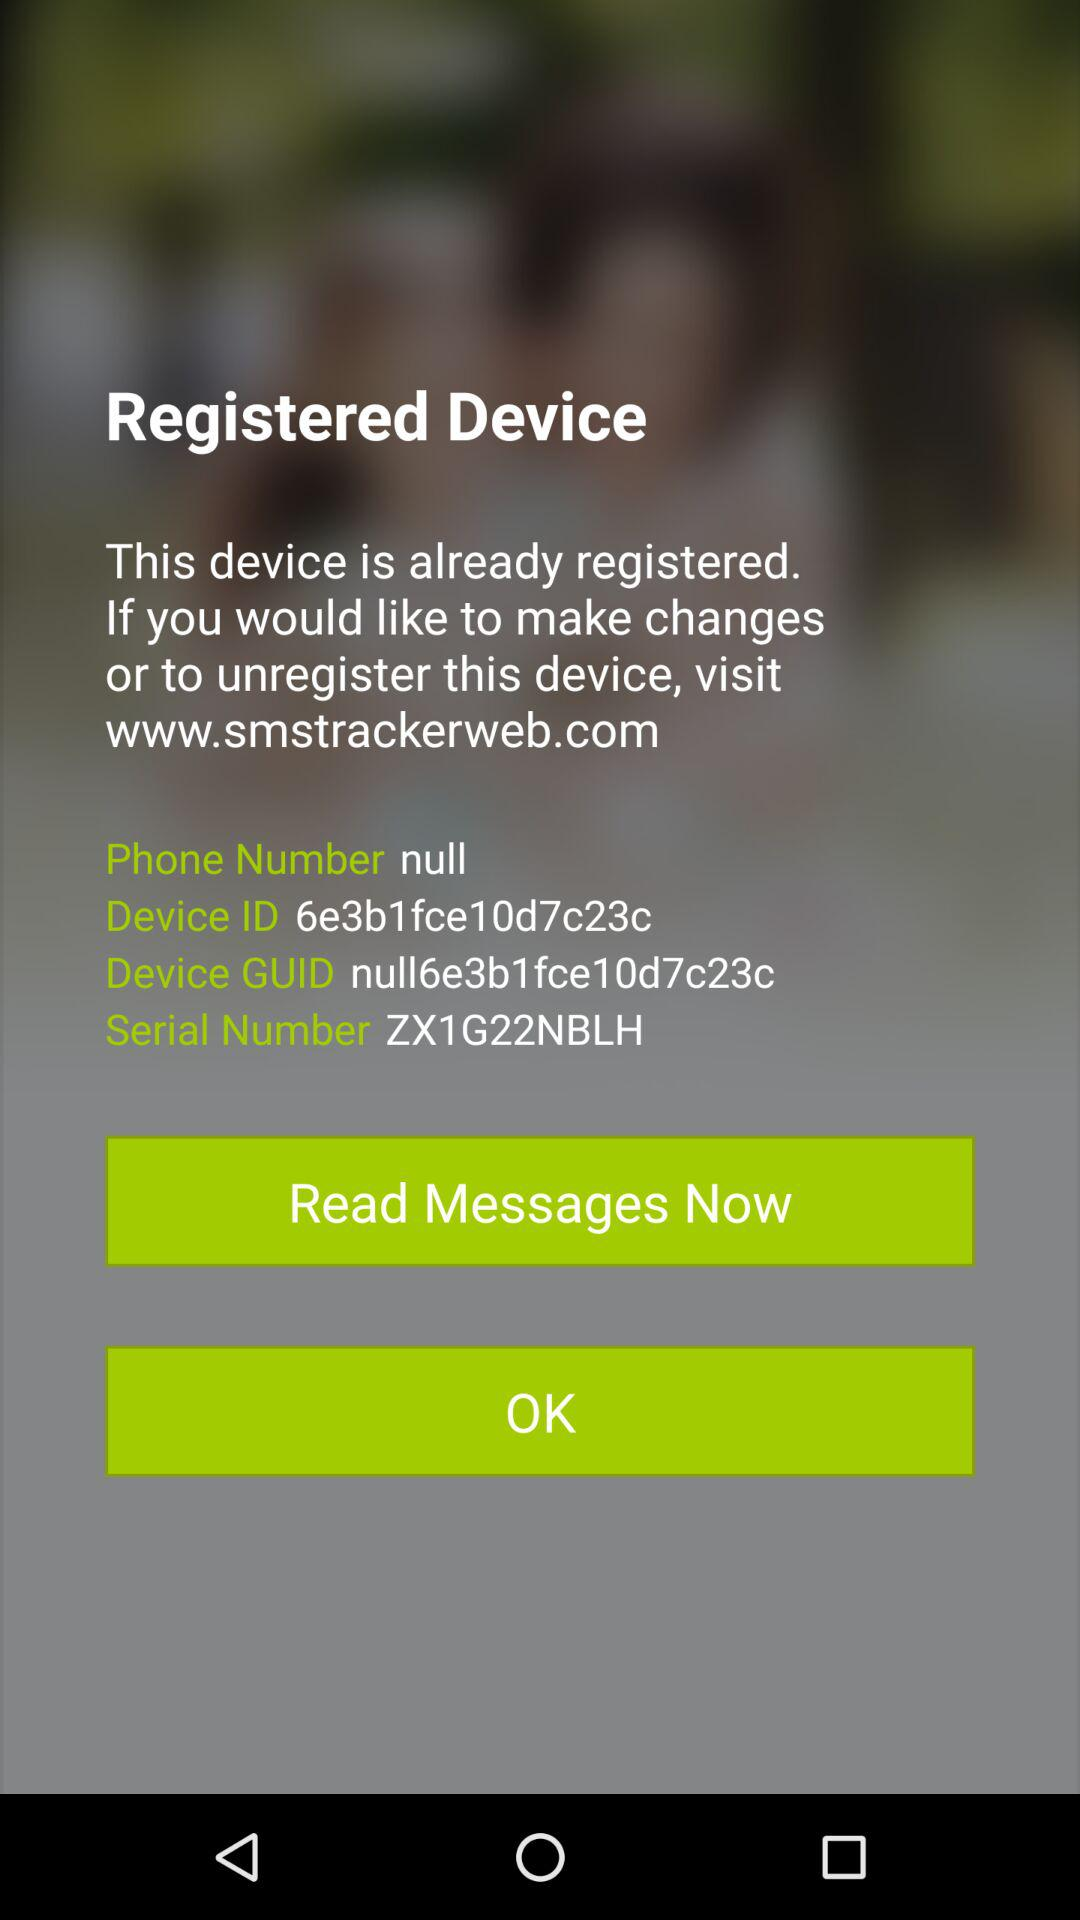What is the device GUID number? The device GUID number is null6e3b1fce10d7c23c. 